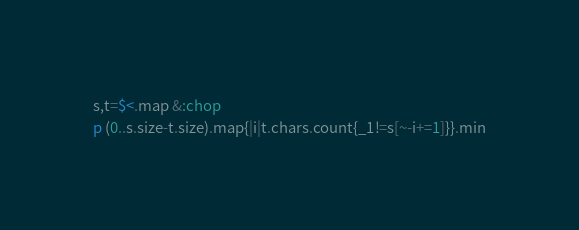<code> <loc_0><loc_0><loc_500><loc_500><_Ruby_>s,t=$<.map &:chop
p (0..s.size-t.size).map{|i|t.chars.count{_1!=s[~-i+=1]}}.min</code> 